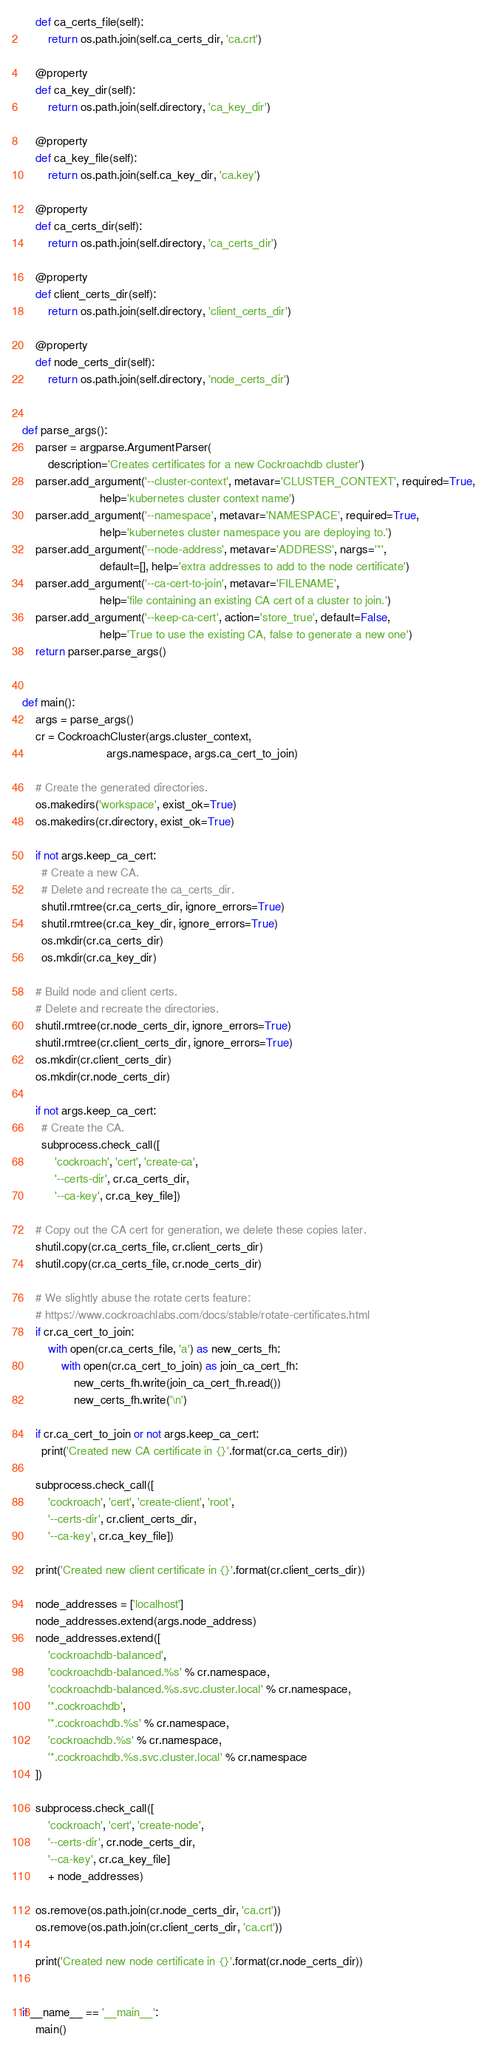<code> <loc_0><loc_0><loc_500><loc_500><_Python_>    def ca_certs_file(self):
        return os.path.join(self.ca_certs_dir, 'ca.crt')

    @property
    def ca_key_dir(self):
        return os.path.join(self.directory, 'ca_key_dir')

    @property
    def ca_key_file(self):
        return os.path.join(self.ca_key_dir, 'ca.key')

    @property
    def ca_certs_dir(self):
        return os.path.join(self.directory, 'ca_certs_dir')

    @property
    def client_certs_dir(self):
        return os.path.join(self.directory, 'client_certs_dir')

    @property
    def node_certs_dir(self):
        return os.path.join(self.directory, 'node_certs_dir')


def parse_args():
    parser = argparse.ArgumentParser(
        description='Creates certificates for a new Cockroachdb cluster')
    parser.add_argument('--cluster-context', metavar='CLUSTER_CONTEXT', required=True,
                        help='kubernetes cluster context name')
    parser.add_argument('--namespace', metavar='NAMESPACE', required=True,
                        help='kubernetes cluster namespace you are deploying to.')
    parser.add_argument('--node-address', metavar='ADDRESS', nargs='*',
                        default=[], help='extra addresses to add to the node certificate')
    parser.add_argument('--ca-cert-to-join', metavar='FILENAME',
                        help='file containing an existing CA cert of a cluster to join.')
    parser.add_argument('--keep-ca-cert', action='store_true', default=False,
                        help='True to use the existing CA, false to generate a new one')
    return parser.parse_args()


def main():
    args = parse_args()
    cr = CockroachCluster(args.cluster_context,
                          args.namespace, args.ca_cert_to_join)

    # Create the generated directories.
    os.makedirs('workspace', exist_ok=True)
    os.makedirs(cr.directory, exist_ok=True)

    if not args.keep_ca_cert:
      # Create a new CA.
      # Delete and recreate the ca_certs_dir.
      shutil.rmtree(cr.ca_certs_dir, ignore_errors=True)
      shutil.rmtree(cr.ca_key_dir, ignore_errors=True)
      os.mkdir(cr.ca_certs_dir)
      os.mkdir(cr.ca_key_dir)

    # Build node and client certs.
    # Delete and recreate the directories.
    shutil.rmtree(cr.node_certs_dir, ignore_errors=True)
    shutil.rmtree(cr.client_certs_dir, ignore_errors=True)
    os.mkdir(cr.client_certs_dir)
    os.mkdir(cr.node_certs_dir)

    if not args.keep_ca_cert:
      # Create the CA.
      subprocess.check_call([
          'cockroach', 'cert', 'create-ca',
          '--certs-dir', cr.ca_certs_dir,
          '--ca-key', cr.ca_key_file])

    # Copy out the CA cert for generation, we delete these copies later.
    shutil.copy(cr.ca_certs_file, cr.client_certs_dir)
    shutil.copy(cr.ca_certs_file, cr.node_certs_dir)

    # We slightly abuse the rotate certs feature:
    # https://www.cockroachlabs.com/docs/stable/rotate-certificates.html
    if cr.ca_cert_to_join:
        with open(cr.ca_certs_file, 'a') as new_certs_fh:
            with open(cr.ca_cert_to_join) as join_ca_cert_fh:
                new_certs_fh.write(join_ca_cert_fh.read())
                new_certs_fh.write('\n')

    if cr.ca_cert_to_join or not args.keep_ca_cert:
      print('Created new CA certificate in {}'.format(cr.ca_certs_dir))

    subprocess.check_call([
        'cockroach', 'cert', 'create-client', 'root',
        '--certs-dir', cr.client_certs_dir,
        '--ca-key', cr.ca_key_file])

    print('Created new client certificate in {}'.format(cr.client_certs_dir))

    node_addresses = ['localhost']
    node_addresses.extend(args.node_address)
    node_addresses.extend([
        'cockroachdb-balanced',
        'cockroachdb-balanced.%s' % cr.namespace,
        'cockroachdb-balanced.%s.svc.cluster.local' % cr.namespace,
        '*.cockroachdb',
        '*.cockroachdb.%s' % cr.namespace,
        'cockroachdb.%s' % cr.namespace,
        '*.cockroachdb.%s.svc.cluster.local' % cr.namespace
    ])

    subprocess.check_call([
        'cockroach', 'cert', 'create-node',
        '--certs-dir', cr.node_certs_dir,
        '--ca-key', cr.ca_key_file]
        + node_addresses)

    os.remove(os.path.join(cr.node_certs_dir, 'ca.crt'))
    os.remove(os.path.join(cr.client_certs_dir, 'ca.crt'))

    print('Created new node certificate in {}'.format(cr.node_certs_dir))


if __name__ == '__main__':
    main()
</code> 